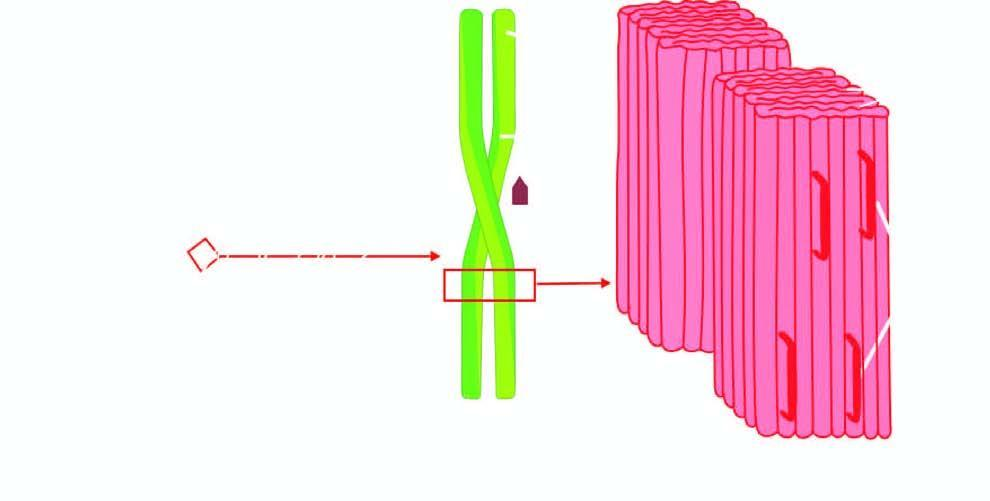does p-component show fibrils having cross -- pleated sheet configuration which produces periodicity that gives the characteristic staining properties of amyloid with congo red and birefringence under polarising microscopy?
Answer the question using a single word or phrase. No 